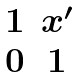Convert formula to latex. <formula><loc_0><loc_0><loc_500><loc_500>\begin{matrix} 1 & x ^ { \prime } \\ 0 & 1 \end{matrix}</formula> 